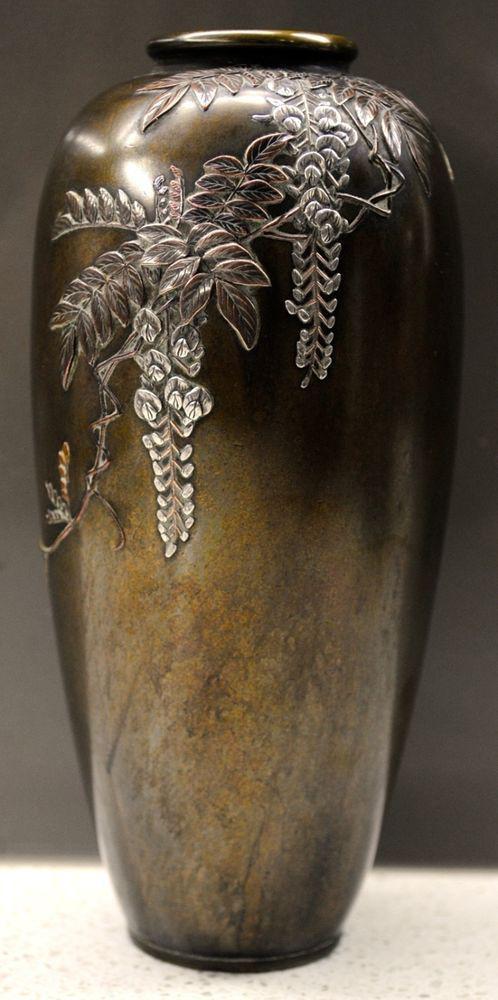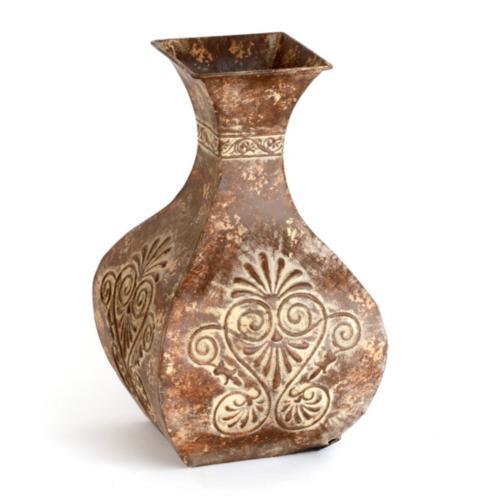The first image is the image on the left, the second image is the image on the right. For the images shown, is this caption "One of the vases has a round opening, and at least one of the vases has a rectangular opening." true? Answer yes or no. Yes. The first image is the image on the left, the second image is the image on the right. Given the left and right images, does the statement "An image includes a vase that tapers to a narrower base from a flat top and has a foliage-themed design on it." hold true? Answer yes or no. Yes. 